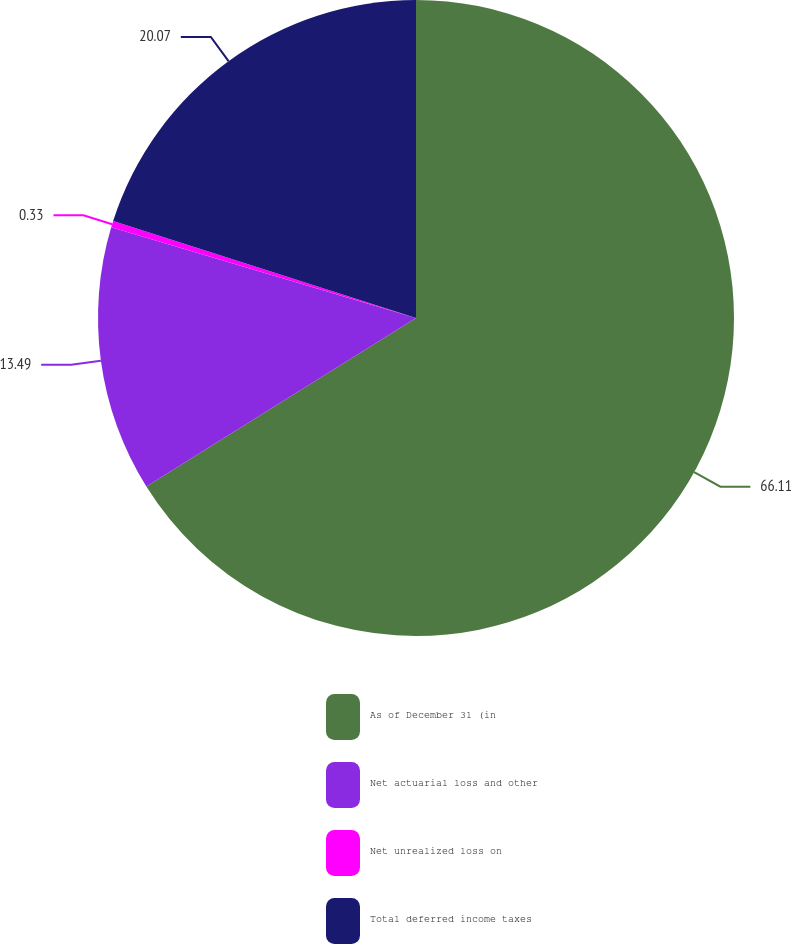Convert chart. <chart><loc_0><loc_0><loc_500><loc_500><pie_chart><fcel>As of December 31 (in<fcel>Net actuarial loss and other<fcel>Net unrealized loss on<fcel>Total deferred income taxes<nl><fcel>66.11%<fcel>13.49%<fcel>0.33%<fcel>20.07%<nl></chart> 